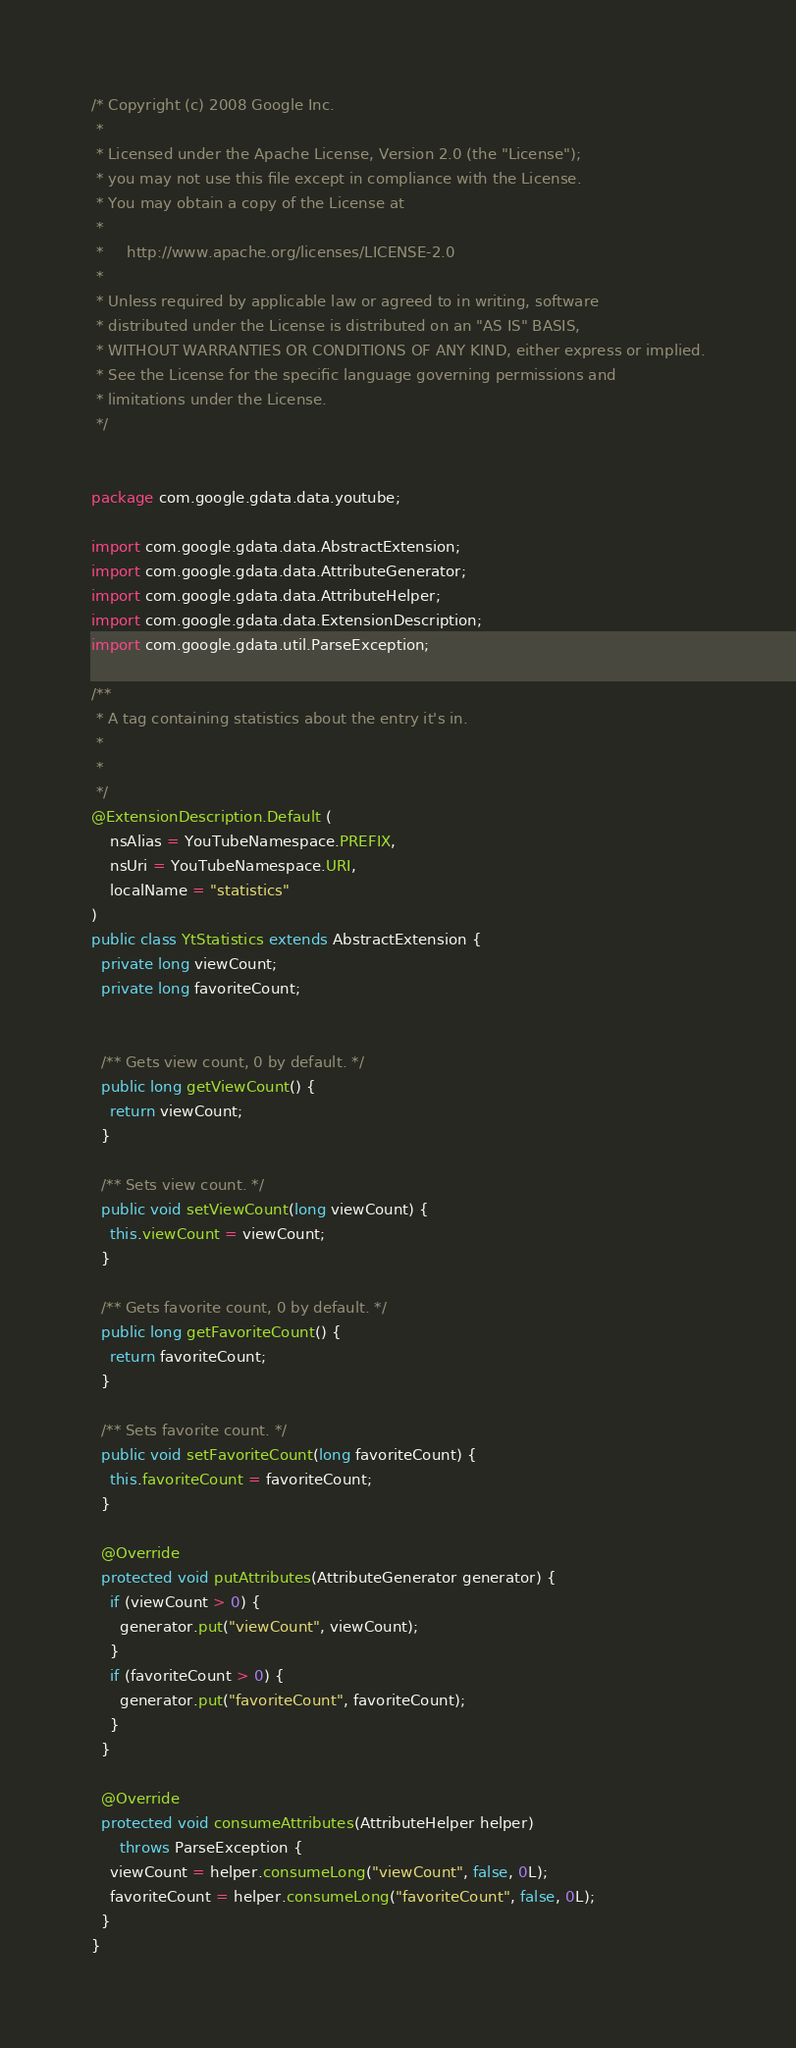Convert code to text. <code><loc_0><loc_0><loc_500><loc_500><_Java_>/* Copyright (c) 2008 Google Inc.
 *
 * Licensed under the Apache License, Version 2.0 (the "License");
 * you may not use this file except in compliance with the License.
 * You may obtain a copy of the License at
 *
 *     http://www.apache.org/licenses/LICENSE-2.0
 *
 * Unless required by applicable law or agreed to in writing, software
 * distributed under the License is distributed on an "AS IS" BASIS,
 * WITHOUT WARRANTIES OR CONDITIONS OF ANY KIND, either express or implied.
 * See the License for the specific language governing permissions and
 * limitations under the License.
 */


package com.google.gdata.data.youtube;

import com.google.gdata.data.AbstractExtension;
import com.google.gdata.data.AttributeGenerator;
import com.google.gdata.data.AttributeHelper;
import com.google.gdata.data.ExtensionDescription;
import com.google.gdata.util.ParseException;

/**
 * A tag containing statistics about the entry it's in.
 *
 * 
 */
@ExtensionDescription.Default (
    nsAlias = YouTubeNamespace.PREFIX,
    nsUri = YouTubeNamespace.URI,
    localName = "statistics"
)
public class YtStatistics extends AbstractExtension {
  private long viewCount;
  private long favoriteCount;


  /** Gets view count, 0 by default. */
  public long getViewCount() {
    return viewCount;
  }

  /** Sets view count. */
  public void setViewCount(long viewCount) {
    this.viewCount = viewCount;
  }

  /** Gets favorite count, 0 by default. */
  public long getFavoriteCount() {
    return favoriteCount;
  }

  /** Sets favorite count. */
  public void setFavoriteCount(long favoriteCount) {
    this.favoriteCount = favoriteCount;
  }

  @Override
  protected void putAttributes(AttributeGenerator generator) {
    if (viewCount > 0) {
      generator.put("viewCount", viewCount);
    }
    if (favoriteCount > 0) {
      generator.put("favoriteCount", favoriteCount);
    }
  }

  @Override
  protected void consumeAttributes(AttributeHelper helper)
      throws ParseException {
    viewCount = helper.consumeLong("viewCount", false, 0L);
    favoriteCount = helper.consumeLong("favoriteCount", false, 0L);
  }
}
</code> 